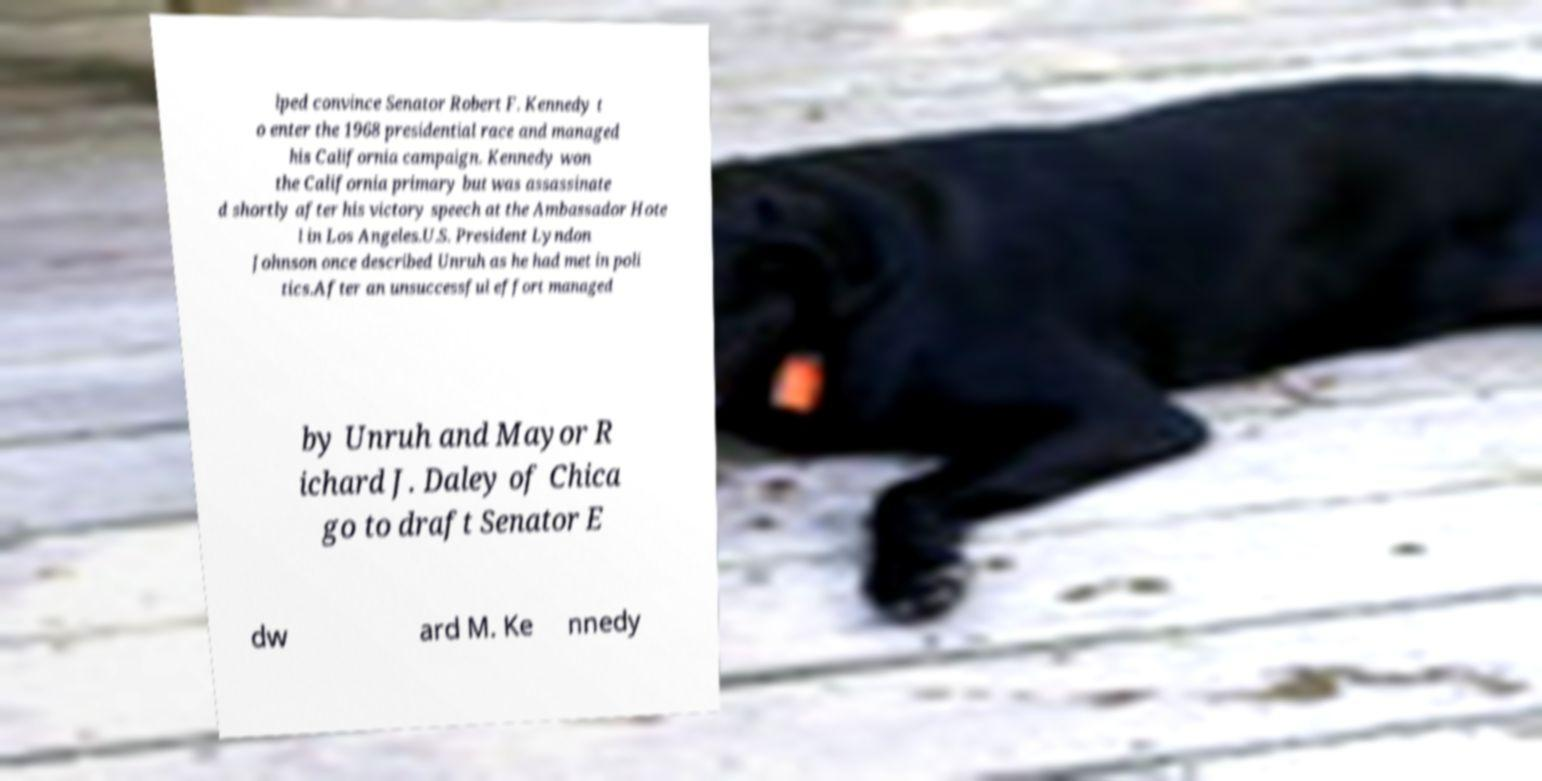What messages or text are displayed in this image? I need them in a readable, typed format. lped convince Senator Robert F. Kennedy t o enter the 1968 presidential race and managed his California campaign. Kennedy won the California primary but was assassinate d shortly after his victory speech at the Ambassador Hote l in Los Angeles.U.S. President Lyndon Johnson once described Unruh as he had met in poli tics.After an unsuccessful effort managed by Unruh and Mayor R ichard J. Daley of Chica go to draft Senator E dw ard M. Ke nnedy 